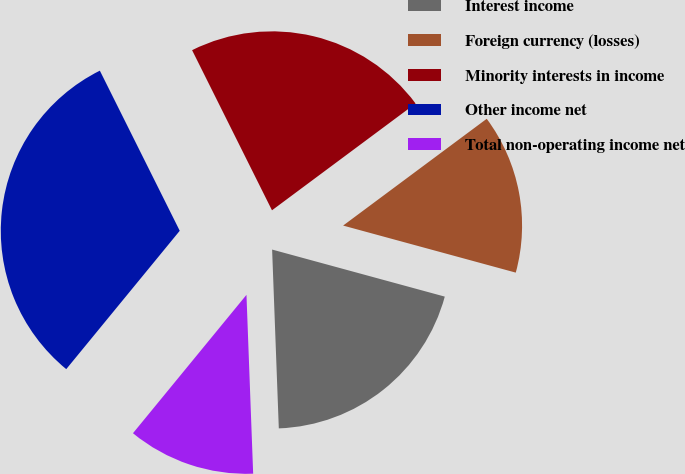Convert chart. <chart><loc_0><loc_0><loc_500><loc_500><pie_chart><fcel>Interest income<fcel>Foreign currency (losses)<fcel>Minority interests in income<fcel>Other income net<fcel>Total non-operating income net<nl><fcel>20.17%<fcel>14.41%<fcel>22.19%<fcel>31.7%<fcel>11.53%<nl></chart> 